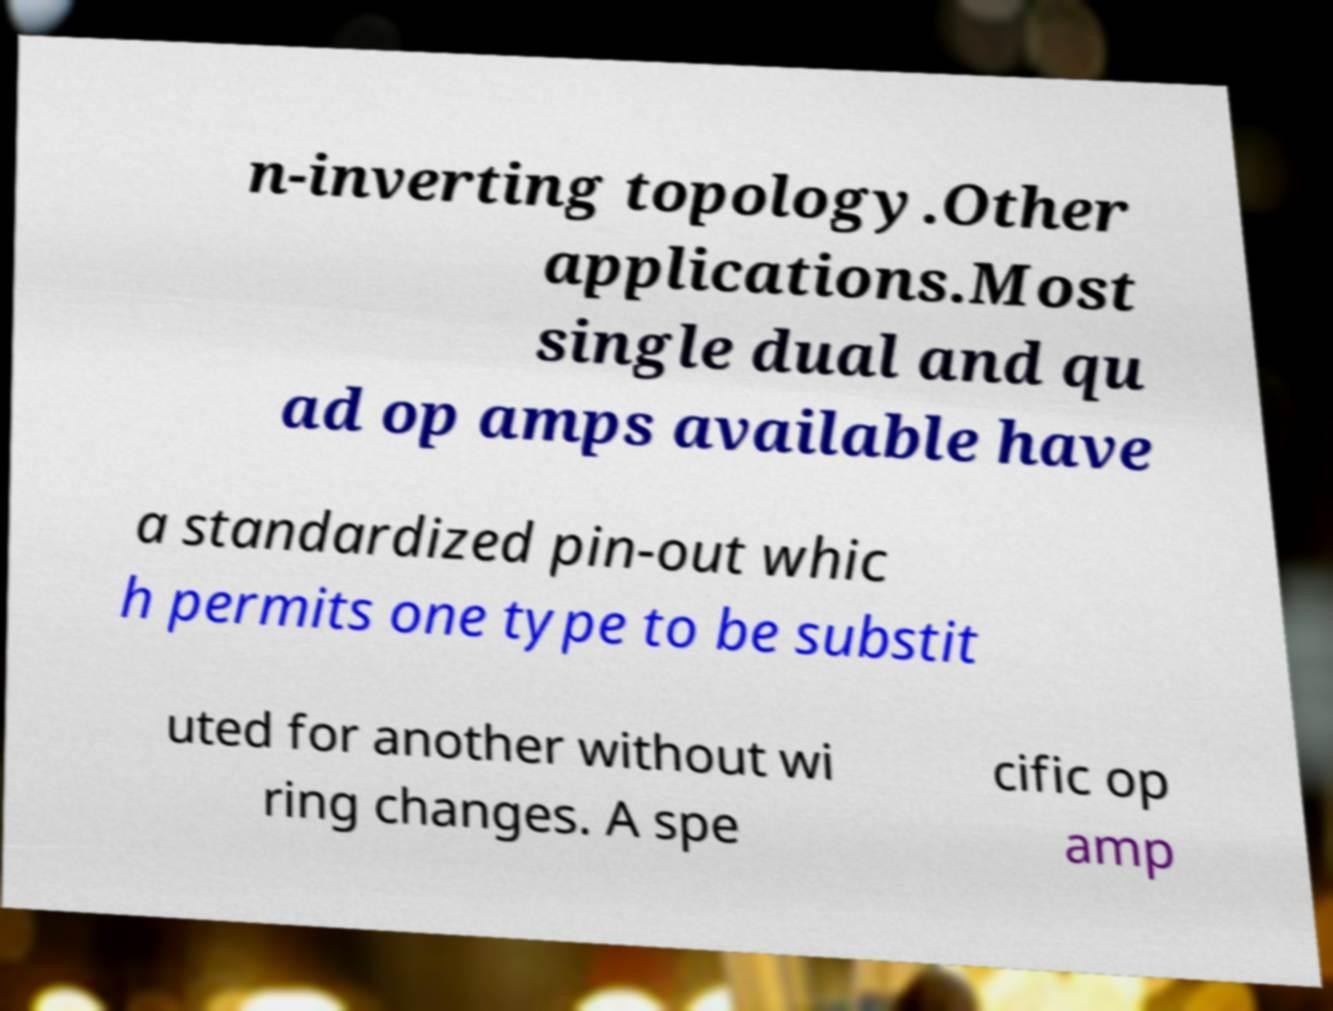Could you assist in decoding the text presented in this image and type it out clearly? n-inverting topology.Other applications.Most single dual and qu ad op amps available have a standardized pin-out whic h permits one type to be substit uted for another without wi ring changes. A spe cific op amp 